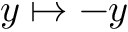Convert formula to latex. <formula><loc_0><loc_0><loc_500><loc_500>y \mapsto - y</formula> 